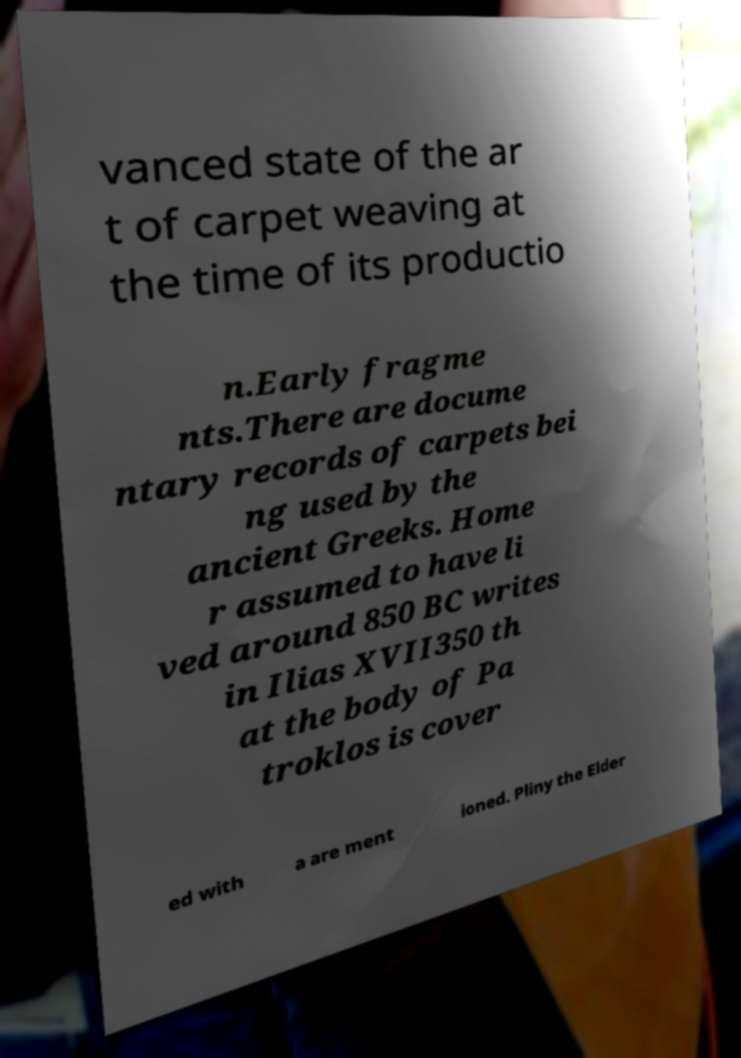Can you accurately transcribe the text from the provided image for me? vanced state of the ar t of carpet weaving at the time of its productio n.Early fragme nts.There are docume ntary records of carpets bei ng used by the ancient Greeks. Home r assumed to have li ved around 850 BC writes in Ilias XVII350 th at the body of Pa troklos is cover ed with a are ment ioned. Pliny the Elder 